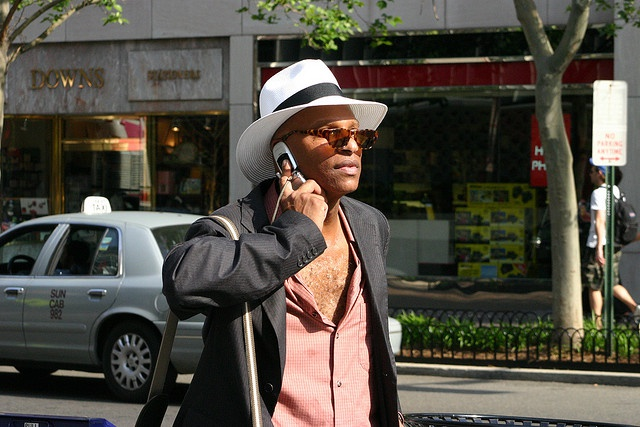Describe the objects in this image and their specific colors. I can see people in black, gray, lightgray, and lightpink tones, car in black, gray, darkgray, and lightgray tones, people in black, gray, and ivory tones, handbag in black, white, gray, and tan tones, and suitcase in black and gray tones in this image. 